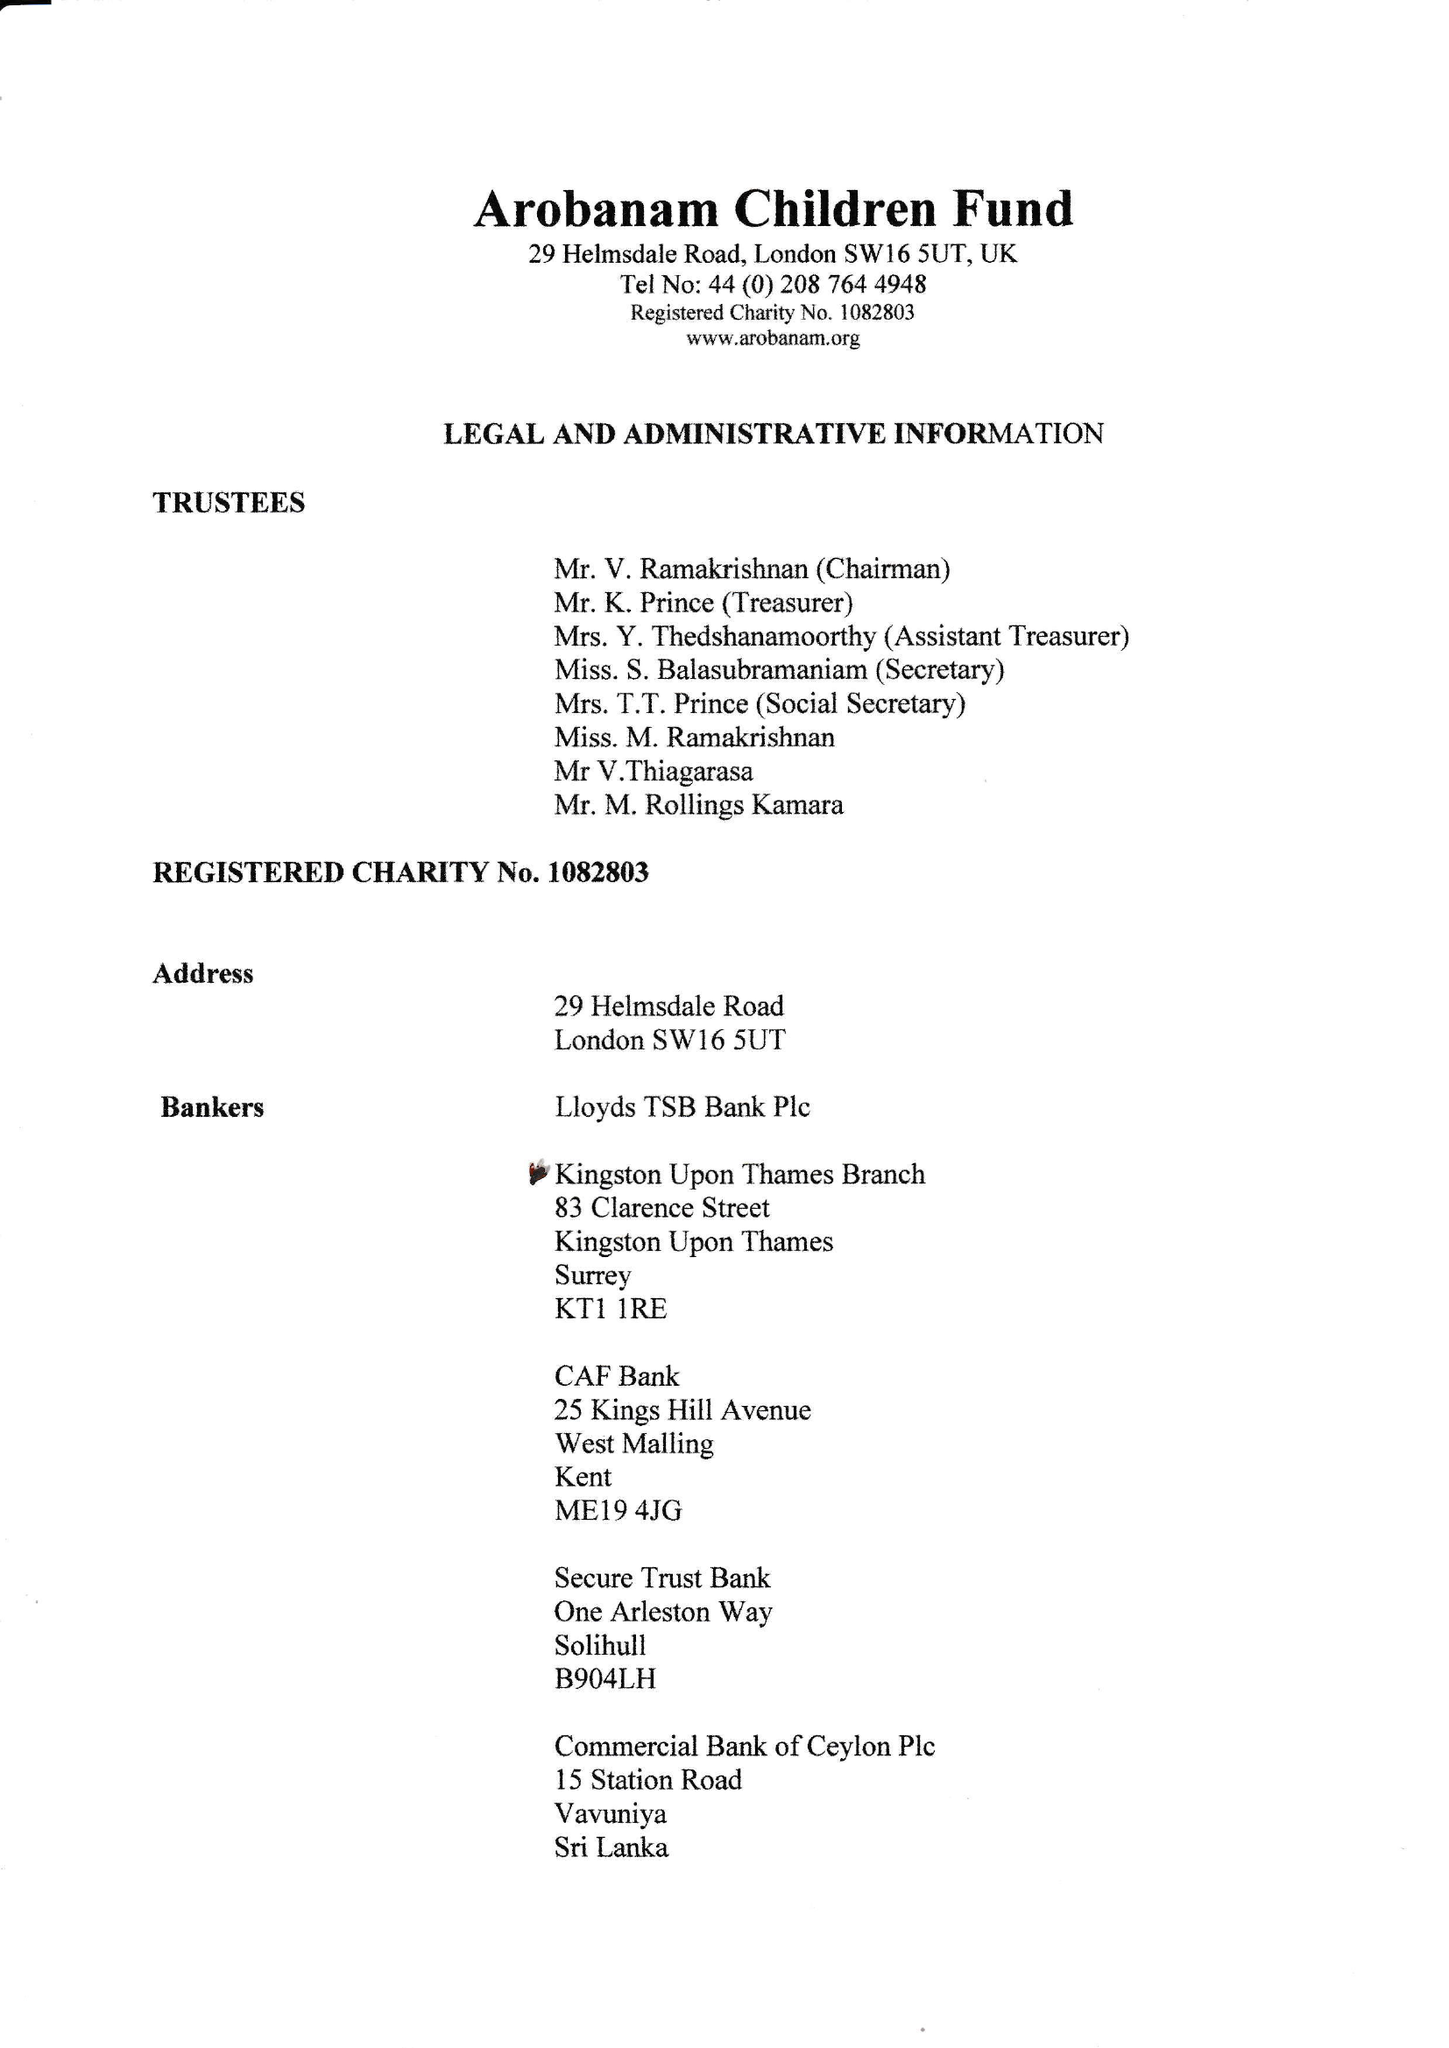What is the value for the address__postcode?
Answer the question using a single word or phrase. SW16 5UT 